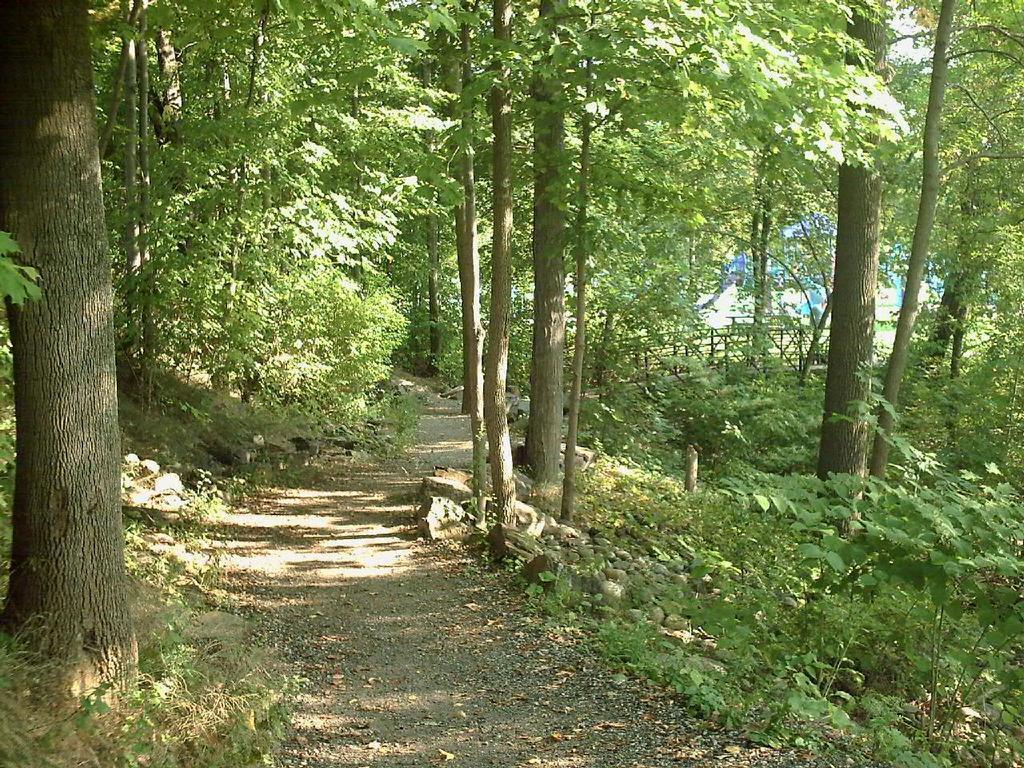Could you give a brief overview of what you see in this image? In this image we can see trees, stones, road, plants, fencing and wall. 